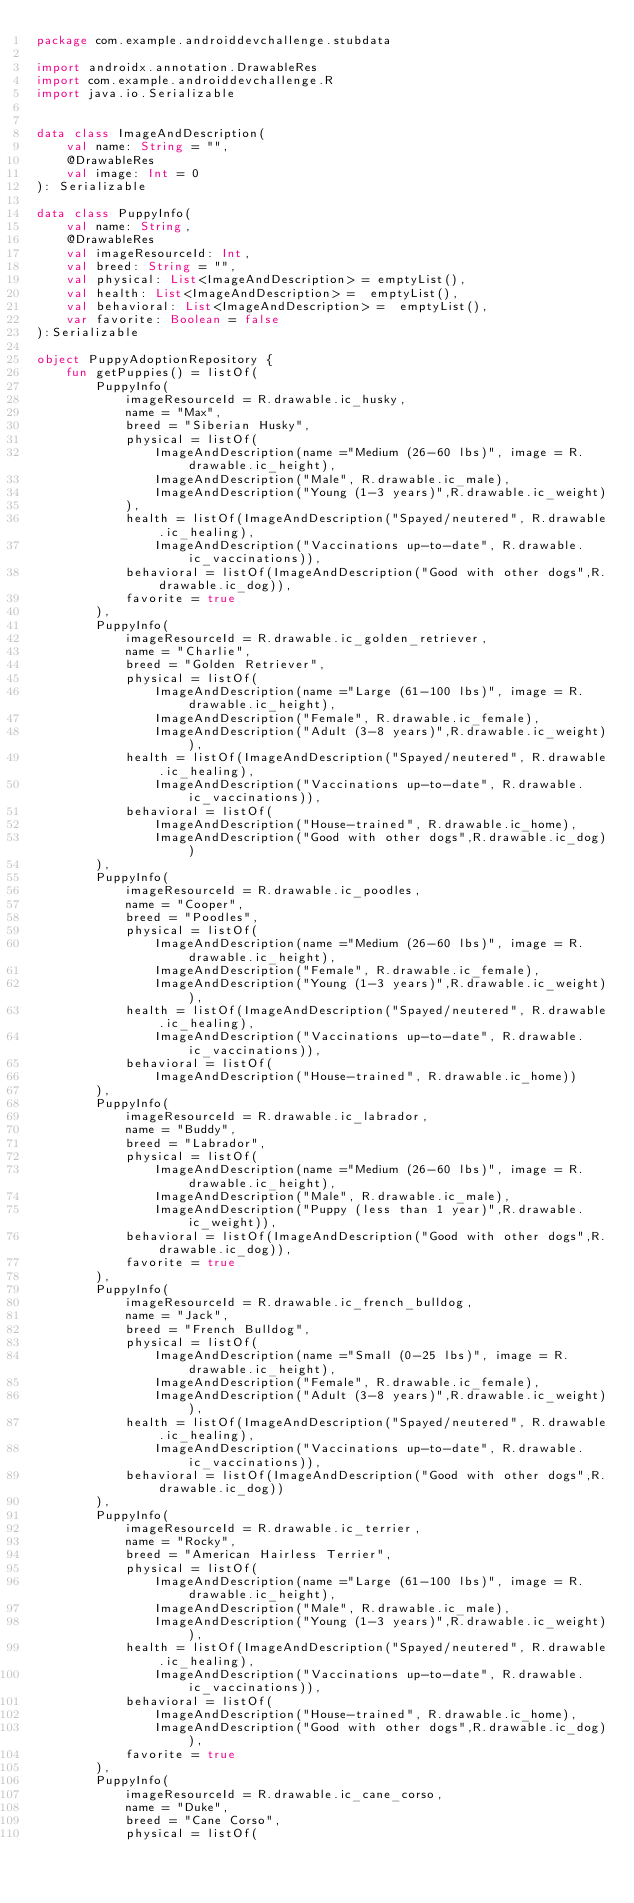<code> <loc_0><loc_0><loc_500><loc_500><_Kotlin_>package com.example.androiddevchallenge.stubdata

import androidx.annotation.DrawableRes
import com.example.androiddevchallenge.R
import java.io.Serializable


data class ImageAndDescription(
    val name: String = "",
    @DrawableRes
    val image: Int = 0
): Serializable

data class PuppyInfo(
    val name: String,
    @DrawableRes
    val imageResourceId: Int,
    val breed: String = "",
    val physical: List<ImageAndDescription> = emptyList(),
    val health: List<ImageAndDescription> =  emptyList(),
    val behavioral: List<ImageAndDescription> =  emptyList(),
    var favorite: Boolean = false
):Serializable

object PuppyAdoptionRepository {
    fun getPuppies() = listOf(
        PuppyInfo(
            imageResourceId = R.drawable.ic_husky,
            name = "Max",
            breed = "Siberian Husky",
            physical = listOf(
                ImageAndDescription(name ="Medium (26-60 lbs)", image = R.drawable.ic_height),
                ImageAndDescription("Male", R.drawable.ic_male),
                ImageAndDescription("Young (1-3 years)",R.drawable.ic_weight)
            ),
            health = listOf(ImageAndDescription("Spayed/neutered", R.drawable.ic_healing),
                ImageAndDescription("Vaccinations up-to-date", R.drawable.ic_vaccinations)),
            behavioral = listOf(ImageAndDescription("Good with other dogs",R.drawable.ic_dog)),
            favorite = true
        ),
        PuppyInfo(
            imageResourceId = R.drawable.ic_golden_retriever,
            name = "Charlie",
            breed = "Golden Retriever",
            physical = listOf(
                ImageAndDescription(name ="Large (61-100 lbs)", image = R.drawable.ic_height),
                ImageAndDescription("Female", R.drawable.ic_female),
                ImageAndDescription("Adult (3-8 years)",R.drawable.ic_weight)),
            health = listOf(ImageAndDescription("Spayed/neutered", R.drawable.ic_healing),
                ImageAndDescription("Vaccinations up-to-date", R.drawable.ic_vaccinations)),
            behavioral = listOf(
                ImageAndDescription("House-trained", R.drawable.ic_home),
                ImageAndDescription("Good with other dogs",R.drawable.ic_dog))
        ),
        PuppyInfo(
            imageResourceId = R.drawable.ic_poodles,
            name = "Cooper",
            breed = "Poodles",
            physical = listOf(
                ImageAndDescription(name ="Medium (26-60 lbs)", image = R.drawable.ic_height),
                ImageAndDescription("Female", R.drawable.ic_female),
                ImageAndDescription("Young (1-3 years)",R.drawable.ic_weight)),
            health = listOf(ImageAndDescription("Spayed/neutered", R.drawable.ic_healing),
                ImageAndDescription("Vaccinations up-to-date", R.drawable.ic_vaccinations)),
            behavioral = listOf(
                ImageAndDescription("House-trained", R.drawable.ic_home))
        ),
        PuppyInfo(
            imageResourceId = R.drawable.ic_labrador,
            name = "Buddy",
            breed = "Labrador",
            physical = listOf(
                ImageAndDescription(name ="Medium (26-60 lbs)", image = R.drawable.ic_height),
                ImageAndDescription("Male", R.drawable.ic_male),
                ImageAndDescription("Puppy (less than 1 year)",R.drawable.ic_weight)),
            behavioral = listOf(ImageAndDescription("Good with other dogs",R.drawable.ic_dog)),
            favorite = true
        ),
        PuppyInfo(
            imageResourceId = R.drawable.ic_french_bulldog,
            name = "Jack",
            breed = "French Bulldog",
            physical = listOf(
                ImageAndDescription(name ="Small (0-25 lbs)", image = R.drawable.ic_height),
                ImageAndDescription("Female", R.drawable.ic_female),
                ImageAndDescription("Adult (3-8 years)",R.drawable.ic_weight)),
            health = listOf(ImageAndDescription("Spayed/neutered", R.drawable.ic_healing),
                ImageAndDescription("Vaccinations up-to-date", R.drawable.ic_vaccinations)),
            behavioral = listOf(ImageAndDescription("Good with other dogs",R.drawable.ic_dog))
        ),
        PuppyInfo(
            imageResourceId = R.drawable.ic_terrier,
            name = "Rocky",
            breed = "American Hairless Terrier",
            physical = listOf(
                ImageAndDescription(name ="Large (61-100 lbs)", image = R.drawable.ic_height),
                ImageAndDescription("Male", R.drawable.ic_male),
                ImageAndDescription("Young (1-3 years)",R.drawable.ic_weight)),
            health = listOf(ImageAndDescription("Spayed/neutered", R.drawable.ic_healing),
                ImageAndDescription("Vaccinations up-to-date", R.drawable.ic_vaccinations)),
            behavioral = listOf(
                ImageAndDescription("House-trained", R.drawable.ic_home),
                ImageAndDescription("Good with other dogs",R.drawable.ic_dog)),
            favorite = true
        ),
        PuppyInfo(
            imageResourceId = R.drawable.ic_cane_corso,
            name = "Duke",
            breed = "Cane Corso",
            physical = listOf(</code> 